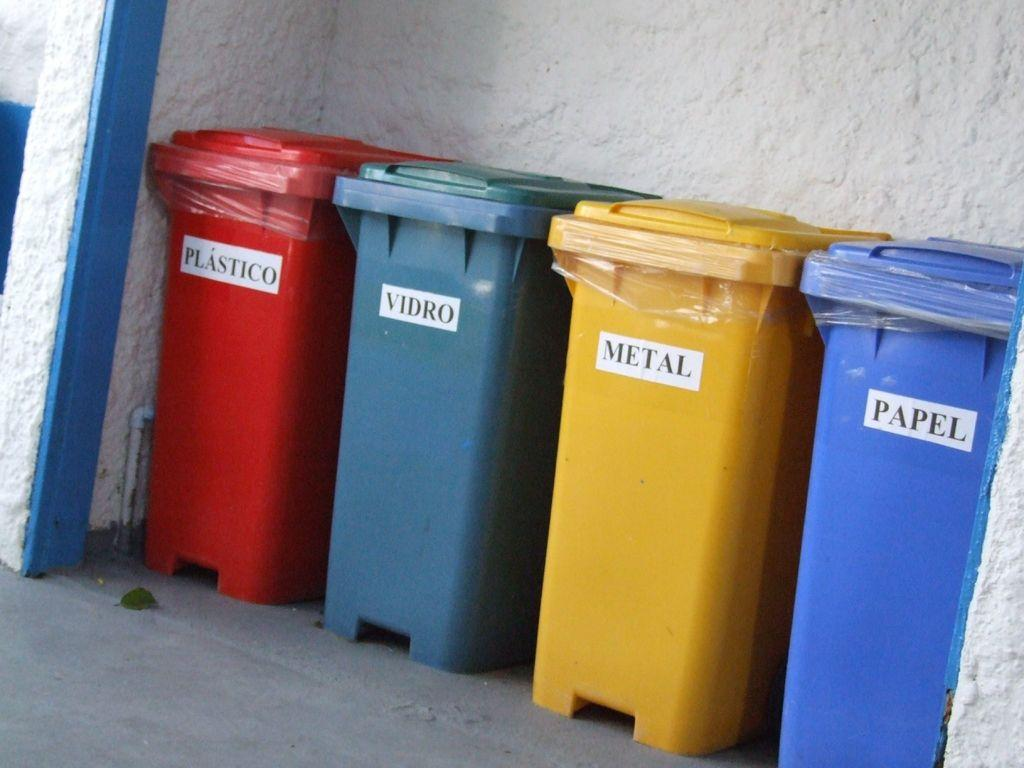<image>
Describe the image concisely. Various colored bins, some are for different recycling pieces and the wording may be in spanish. 